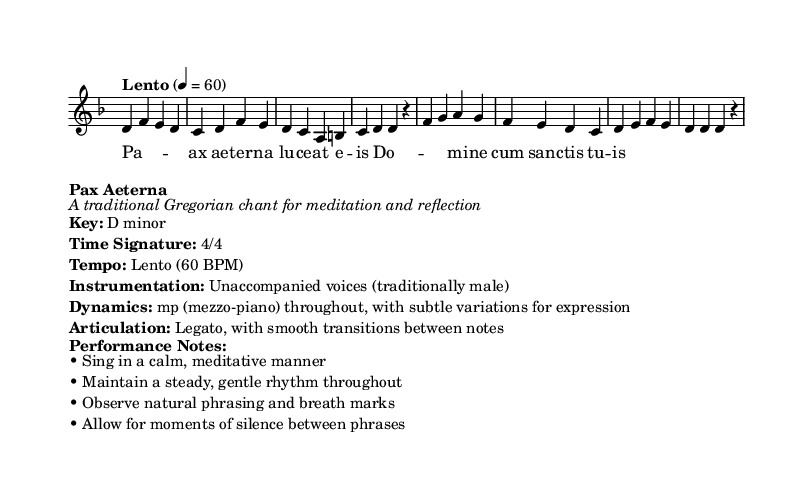What is the key signature of this music? The key signature is D minor, which typically has one flat (B flat) corresponding to the notes present in the piece.
Answer: D minor What is the time signature of this piece? The time signature is noted as 4/4, meaning there are four beats in each measure and the quarter note receives one beat.
Answer: 4/4 What is the tempo marking given for this chant? The tempo marking is "Lento" indicating a slow tempo at approximately 60 beats per minute.
Answer: Lento (60 BPM) How is the melody articulated in this piece? The articulation is indicated to be legato, which means that the notes should be smoothly connected without any breaks.
Answer: Legato What type of voices is traditionally used for this chant? The instrumentation specifies unaccompanied voices, traditionally male, which is characteristic of Gregorian chant.
Answer: Unaccompanied voices (traditionally male) What dynamic level is indicated throughout the piece? The dynamics are specified as mezzo-piano, suggesting a moderately soft volume is to be maintained consistently.
Answer: mp (mezzo-piano) What is emphasized during the performance of this chant? The performance notes emphasize singing in a calm, meditative manner and maintaining a steady, gentle rhythm, while observing phrasing and breathing.
Answer: Calm, meditative manner 